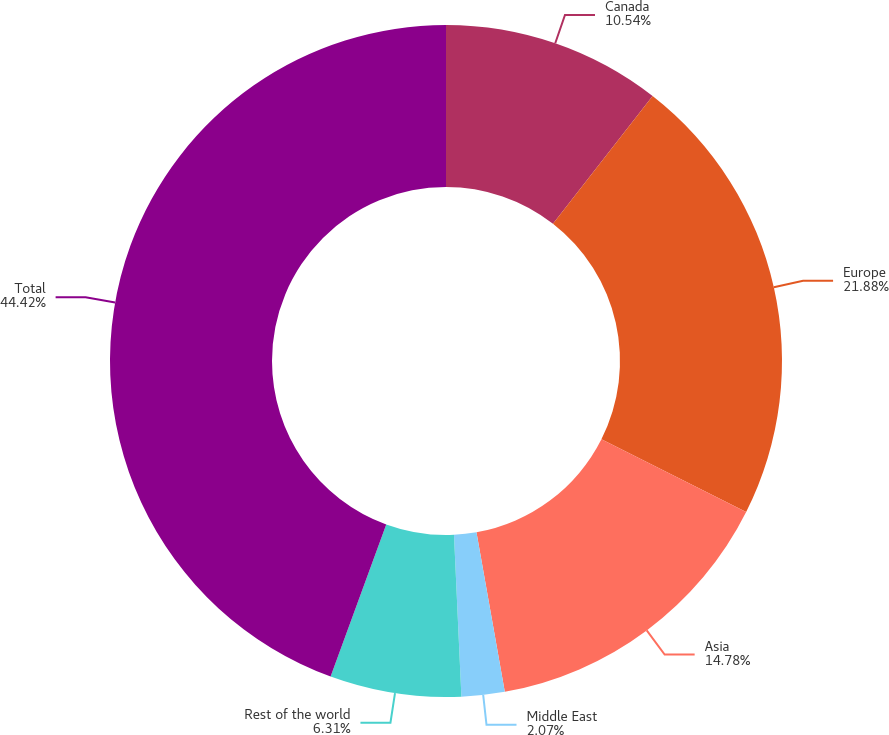Convert chart to OTSL. <chart><loc_0><loc_0><loc_500><loc_500><pie_chart><fcel>Canada<fcel>Europe<fcel>Asia<fcel>Middle East<fcel>Rest of the world<fcel>Total<nl><fcel>10.54%<fcel>21.88%<fcel>14.78%<fcel>2.07%<fcel>6.31%<fcel>44.42%<nl></chart> 